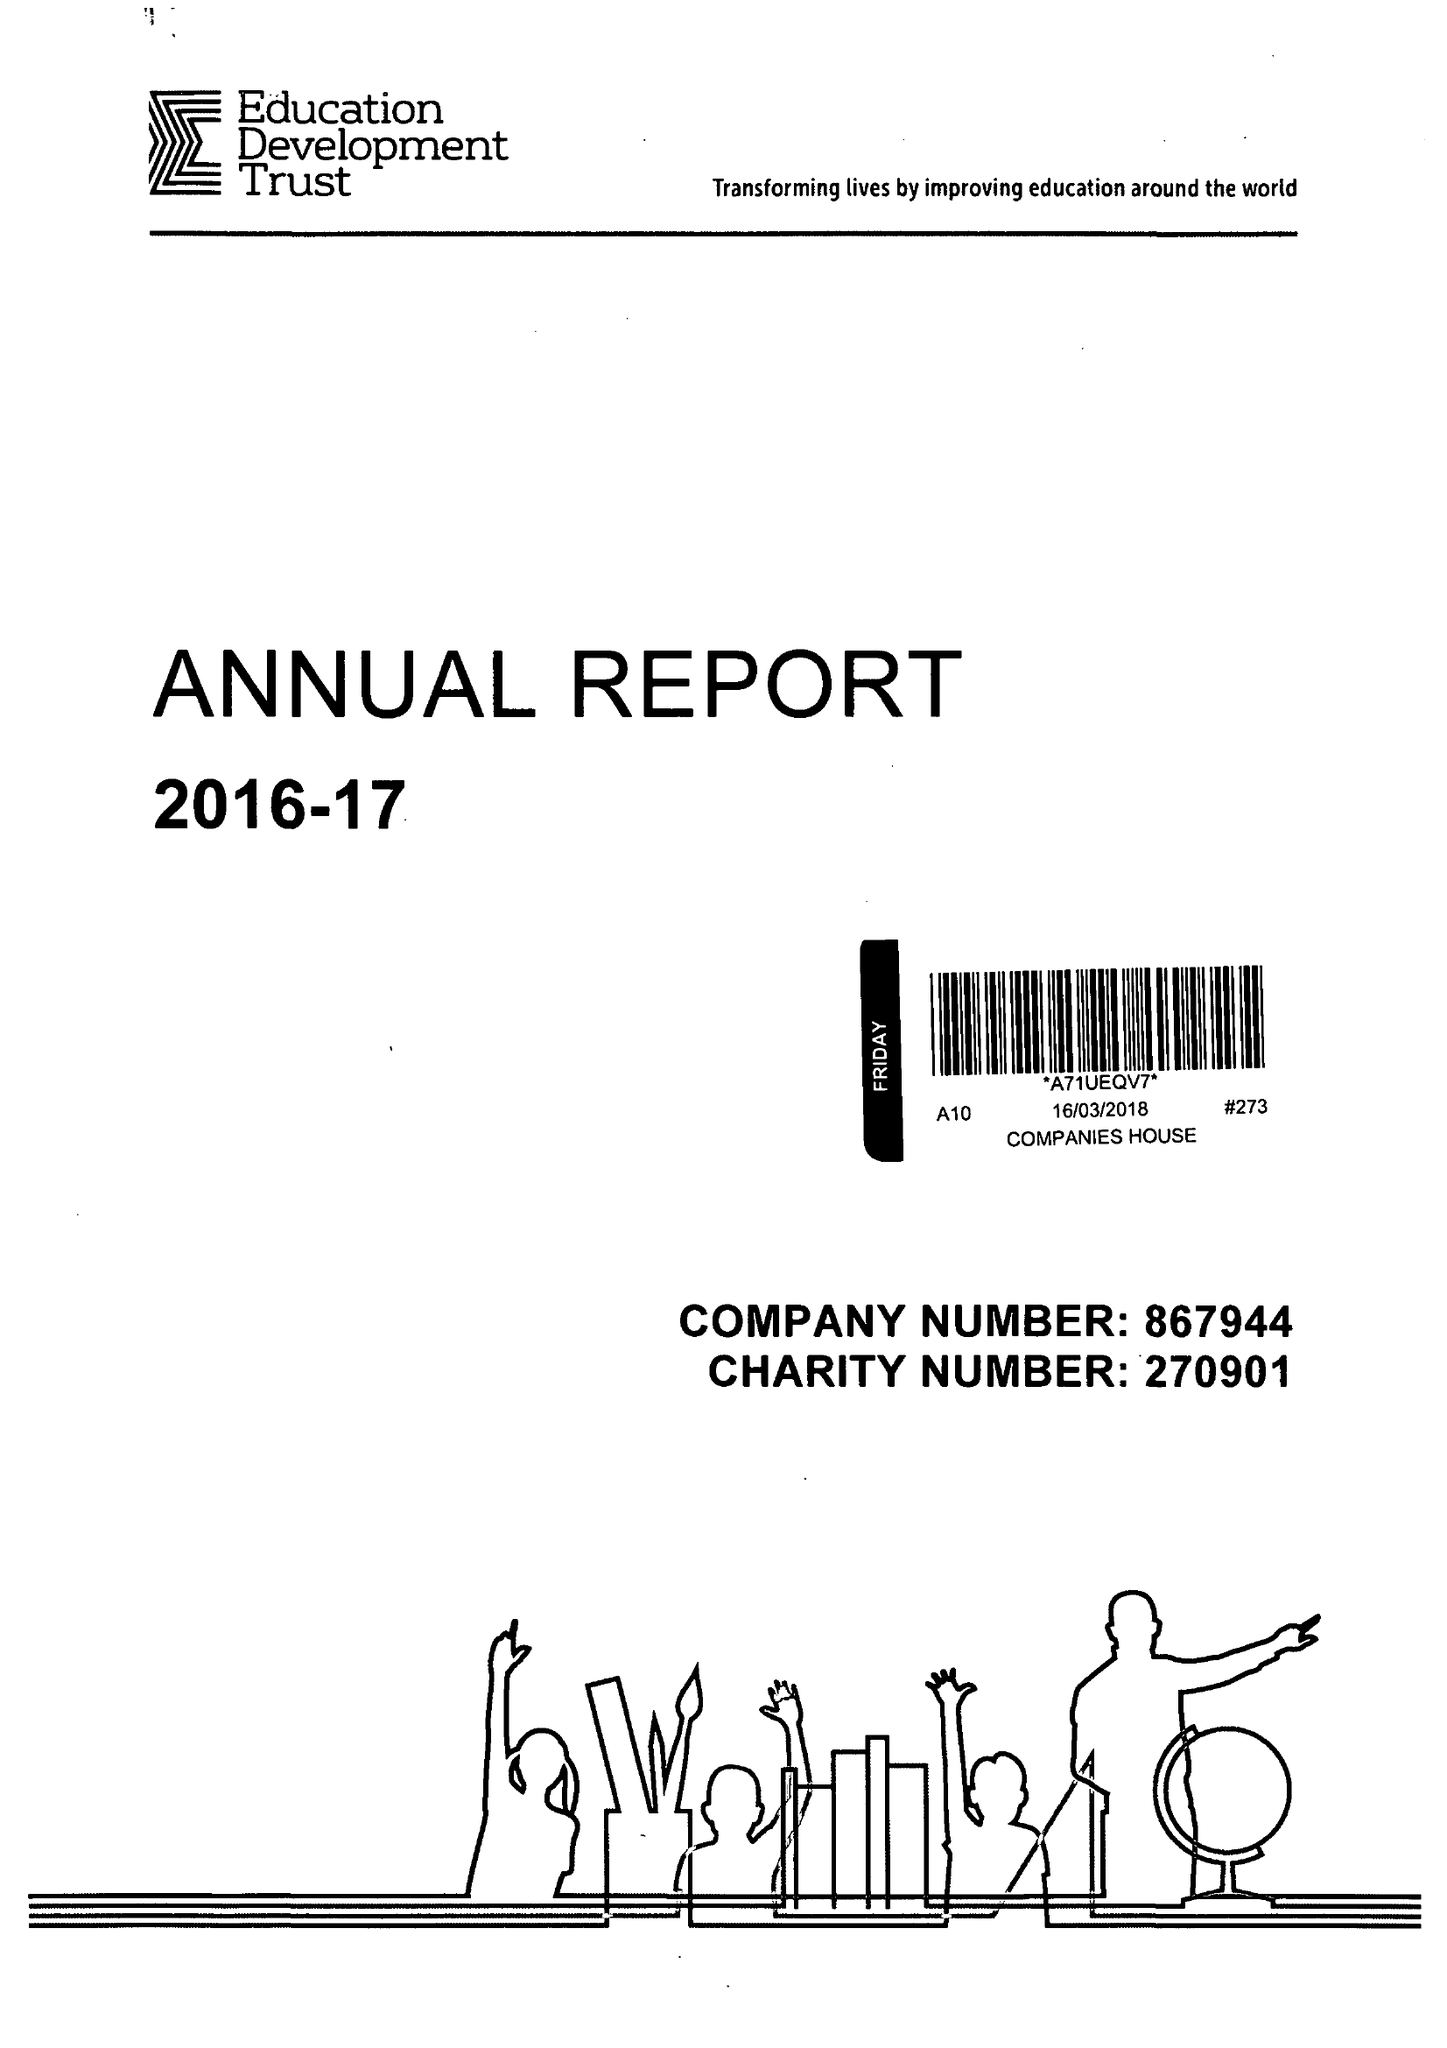What is the value for the charity_number?
Answer the question using a single word or phrase. 270901 